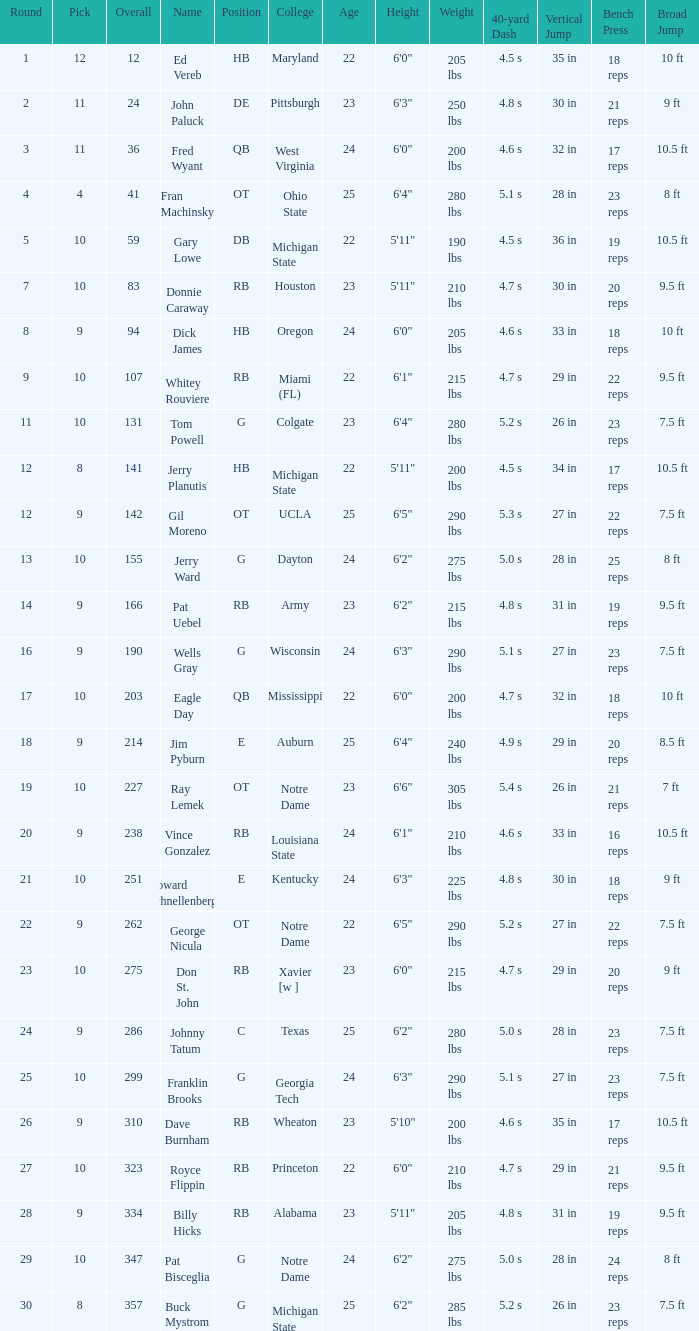What is the average number of rounds for billy hicks who had an overall pick number bigger than 310? 28.0. 